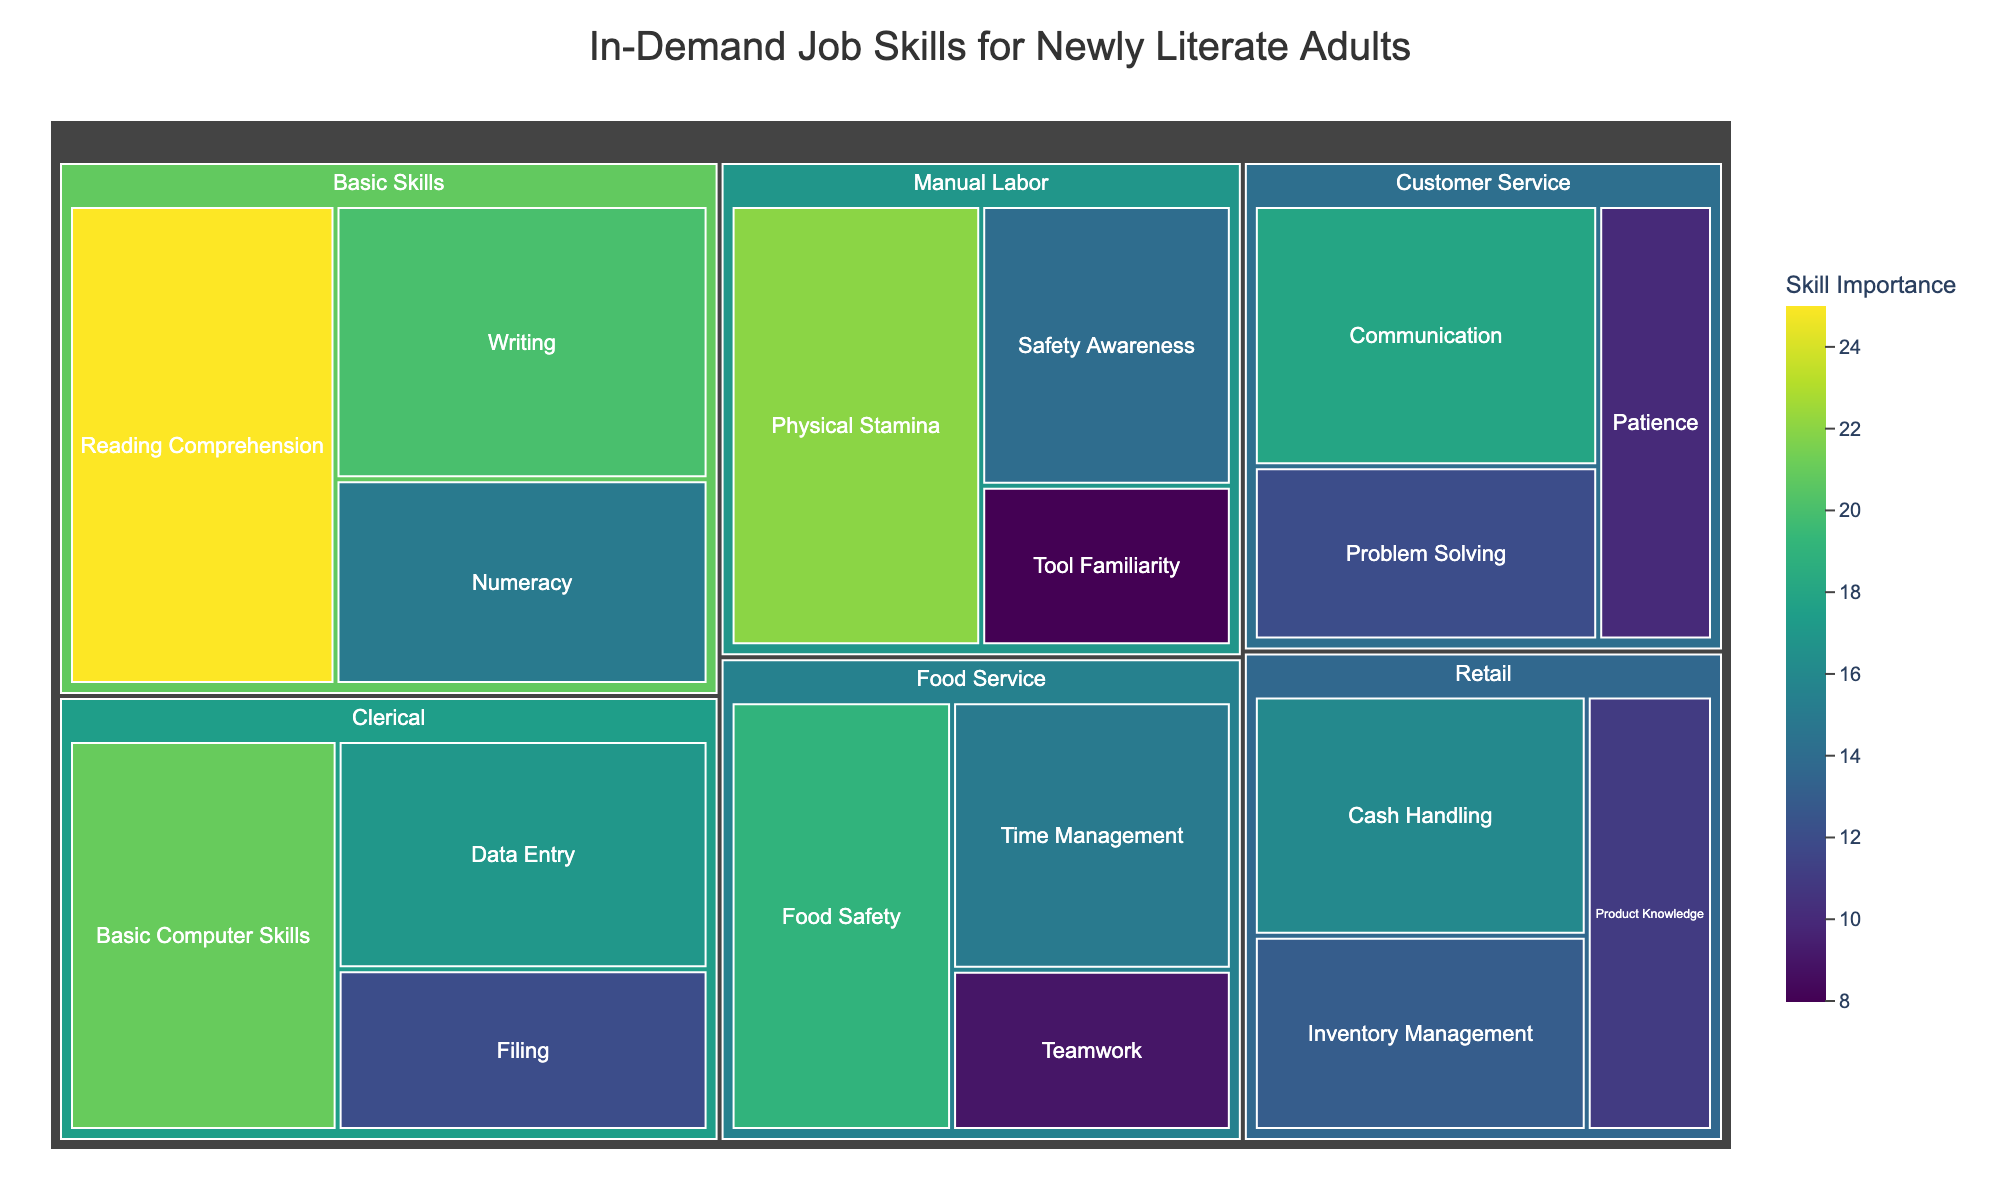What is the most important subcategory within Basic Skills? The largest section within the Basic Skills category, indicated by the highest value, is Reading Comprehension with a value of 25.
Answer: Reading Comprehension Which subcategory has the lowest importance value and what is it? The smallest section in the treemap shows Tool Familiarity under Manual Labor with a value of 8.
Answer: Tool Familiarity, 8 Compare the importance of Writing in Basic Skills and Data Entry in Clerical. Which is higher? Writing has a value of 20 and Data Entry has a value of 17. Thus, Writing is higher in importance.
Answer: Writing What is the total importance value for all subcategories under the Food Service category? Adding up the values for Food Safety (19), Time Management (15), and Teamwork (9) gives a total of 19 + 15 + 9 = 43.
Answer: 43 Determine the category with the highest cumulative value. Sum the values for each category: Basic Skills (25+20+15=60), Customer Service (18+12+10=40), Manual Labor (22+14+8=44), Retail (16+13+11=40), Food Service (19+15+9=43), and Clerical (17+12+21=50). Basic Skills has the highest total value of 60.
Answer: Basic Skills Which subcategory in Retail shows greater importance, Cash Handling or Inventory Management? Cash Handling has a value of 16 and Inventory Management has a value of 13. Thus, Cash Handling is of greater importance.
Answer: Cash Handling Is Safety Awareness more important than Patience according to the treemap? Safety Awareness under Manual Labor has a value of 14 while Patience under Customer Service has a value of 10. Therefore, Safety Awareness is more important.
Answer: Yes What is the mean importance of subcategories within Customer Service? Calculating the mean: (Communication (18) + Problem Solving (12) + Patience (10)) / 3 = (18 + 12 + 10) / 3 = 40 / 3 ≈ 13.33.
Answer: 13.33 Identify the subcategory with the highest value across all categories. By visual inspection, Reading Comprehension in Basic Skills has the highest value of 25.
Answer: Reading Comprehension, 25 How does the value of Basic Computer Skills compare to Physical Stamina? Basic Computer Skills has a value of 21, and Physical Stamina has a value of 22. Physical Stamina is slightly higher.
Answer: Physical Stamina 